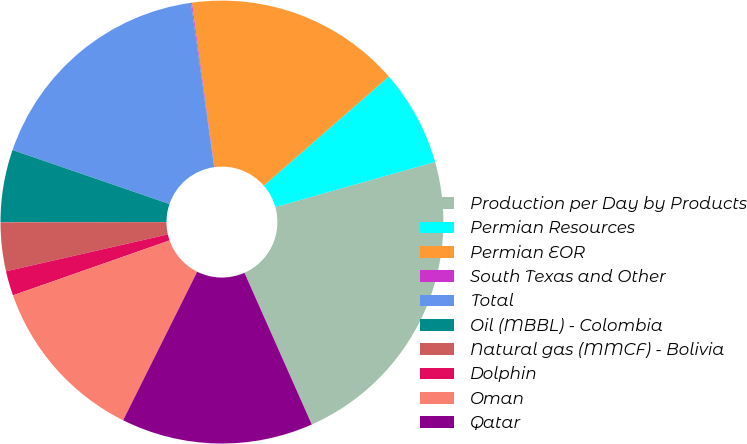Convert chart. <chart><loc_0><loc_0><loc_500><loc_500><pie_chart><fcel>Production per Day by Products<fcel>Permian Resources<fcel>Permian EOR<fcel>South Texas and Other<fcel>Total<fcel>Oil (MBBL) - Colombia<fcel>Natural gas (MMCF) - Bolivia<fcel>Dolphin<fcel>Oman<fcel>Qatar<nl><fcel>22.73%<fcel>7.04%<fcel>15.75%<fcel>0.06%<fcel>17.5%<fcel>5.29%<fcel>3.55%<fcel>1.8%<fcel>12.27%<fcel>14.01%<nl></chart> 